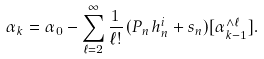Convert formula to latex. <formula><loc_0><loc_0><loc_500><loc_500>\alpha _ { k } = \alpha _ { 0 } - \sum _ { \ell = 2 } ^ { \infty } \frac { 1 } { \ell ! } \, ( P _ { n } h ^ { i } _ { n } + s _ { n } ) [ \alpha _ { k - 1 } ^ { \wedge \ell } ] .</formula> 